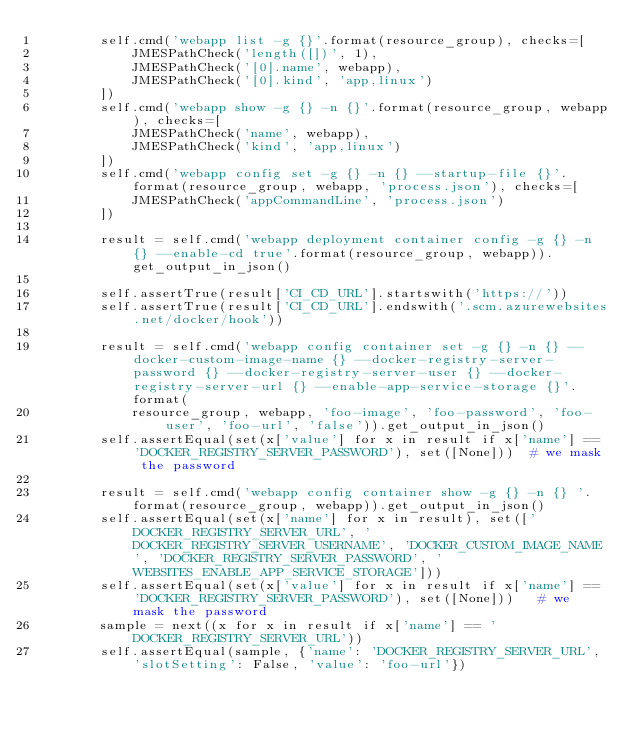Convert code to text. <code><loc_0><loc_0><loc_500><loc_500><_Python_>        self.cmd('webapp list -g {}'.format(resource_group), checks=[
            JMESPathCheck('length([])', 1),
            JMESPathCheck('[0].name', webapp),
            JMESPathCheck('[0].kind', 'app,linux')
        ])
        self.cmd('webapp show -g {} -n {}'.format(resource_group, webapp), checks=[
            JMESPathCheck('name', webapp),
            JMESPathCheck('kind', 'app,linux')
        ])
        self.cmd('webapp config set -g {} -n {} --startup-file {}'.format(resource_group, webapp, 'process.json'), checks=[
            JMESPathCheck('appCommandLine', 'process.json')
        ])

        result = self.cmd('webapp deployment container config -g {} -n {} --enable-cd true'.format(resource_group, webapp)).get_output_in_json()

        self.assertTrue(result['CI_CD_URL'].startswith('https://'))
        self.assertTrue(result['CI_CD_URL'].endswith('.scm.azurewebsites.net/docker/hook'))

        result = self.cmd('webapp config container set -g {} -n {} --docker-custom-image-name {} --docker-registry-server-password {} --docker-registry-server-user {} --docker-registry-server-url {} --enable-app-service-storage {}'.format(
            resource_group, webapp, 'foo-image', 'foo-password', 'foo-user', 'foo-url', 'false')).get_output_in_json()
        self.assertEqual(set(x['value'] for x in result if x['name'] == 'DOCKER_REGISTRY_SERVER_PASSWORD'), set([None]))  # we mask the password

        result = self.cmd('webapp config container show -g {} -n {} '.format(resource_group, webapp)).get_output_in_json()
        self.assertEqual(set(x['name'] for x in result), set(['DOCKER_REGISTRY_SERVER_URL', 'DOCKER_REGISTRY_SERVER_USERNAME', 'DOCKER_CUSTOM_IMAGE_NAME', 'DOCKER_REGISTRY_SERVER_PASSWORD', 'WEBSITES_ENABLE_APP_SERVICE_STORAGE']))
        self.assertEqual(set(x['value'] for x in result if x['name'] == 'DOCKER_REGISTRY_SERVER_PASSWORD'), set([None]))   # we mask the password
        sample = next((x for x in result if x['name'] == 'DOCKER_REGISTRY_SERVER_URL'))
        self.assertEqual(sample, {'name': 'DOCKER_REGISTRY_SERVER_URL', 'slotSetting': False, 'value': 'foo-url'})</code> 